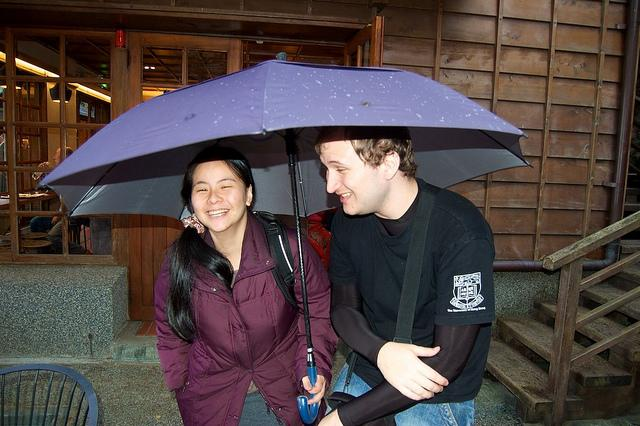What is starting here?

Choices:
A) snow
B) fight
C) rain
D) sleet rain 